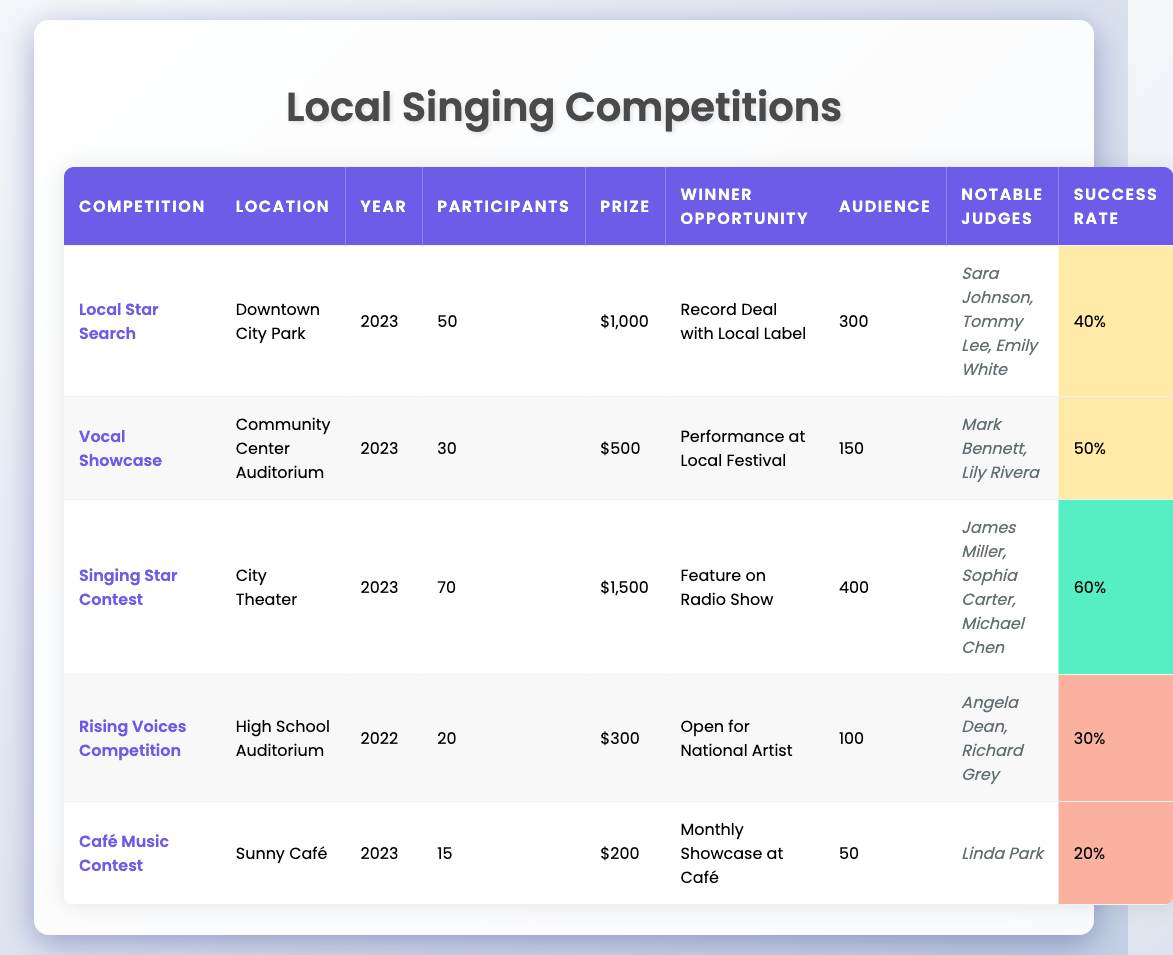What is the prize amount for the Singing Star Contest? From the table, the Singing Star Contest's prize amount is clearly listed as $1,500.
Answer: $1,500 How many participants were there in total for the 2023 competitions? The 2023 competitions are Local Star Search, Vocal Showcase, Singing Star Contest, and Café Music Contest. The total participants = 50 + 30 + 70 + 15 = 165.
Answer: 165 Who were the notable judges for the Vocal Showcase? The table lists the notable judges for the Vocal Showcase as Mark Bennett and Lily Rivera.
Answer: Mark Bennett, Lily Rivera Which competition had the highest audience size? By examining the audience sizes listed, Singing Star Contest had the highest audience size of 400 people compared to others.
Answer: 400 What is the success rate for the Café Music Contest? The success rate for the Café Music Contest is denoted as 20% in the table.
Answer: 20% Did the Rising Voices Competition have more participants than the Café Music Contest? The Rising Voices Competition had 20 participants while the Café Music Contest had only 15. Since 20 is greater than 15, the statement is true.
Answer: Yes What is the average prize amount for all competitions in 2023? The prizes in 2023 are $1,000 (Local Star Search), $500 (Vocal Showcase), $1,500 (Singing Star Contest), and $200 (Café Music Contest). The total prize amount = $1,000 + $500 + $1,500 + $200 = $3,200. The average = $3,200 / 4 = $800.
Answer: $800 Which competition has the lowest outcome success rate? By reviewing the success rates, the Café Music Contest has the lowest success rate at 20%.
Answer: 20% How many notable judges were present at the Singing Star Contest? The notable judges listed for the Singing Star Contest are James Miller, Sophia Carter, and Michael Chen, totaling three judges.
Answer: 3 What is the difference in the audience size between the Singing Star Contest and the Café Music Contest? The audience for Singing Star Contest is 400, and for the Café Music Contest, it is 50. The difference is 400 - 50 = 350.
Answer: 350 If you combined the prize amounts of the Vocal Showcase and the Rising Voices Competition, what would be the total? The prize for Vocal Showcase is $500 and for Rising Voices Competition is $300. Combining them gives $500 + $300 = $800.
Answer: $800 